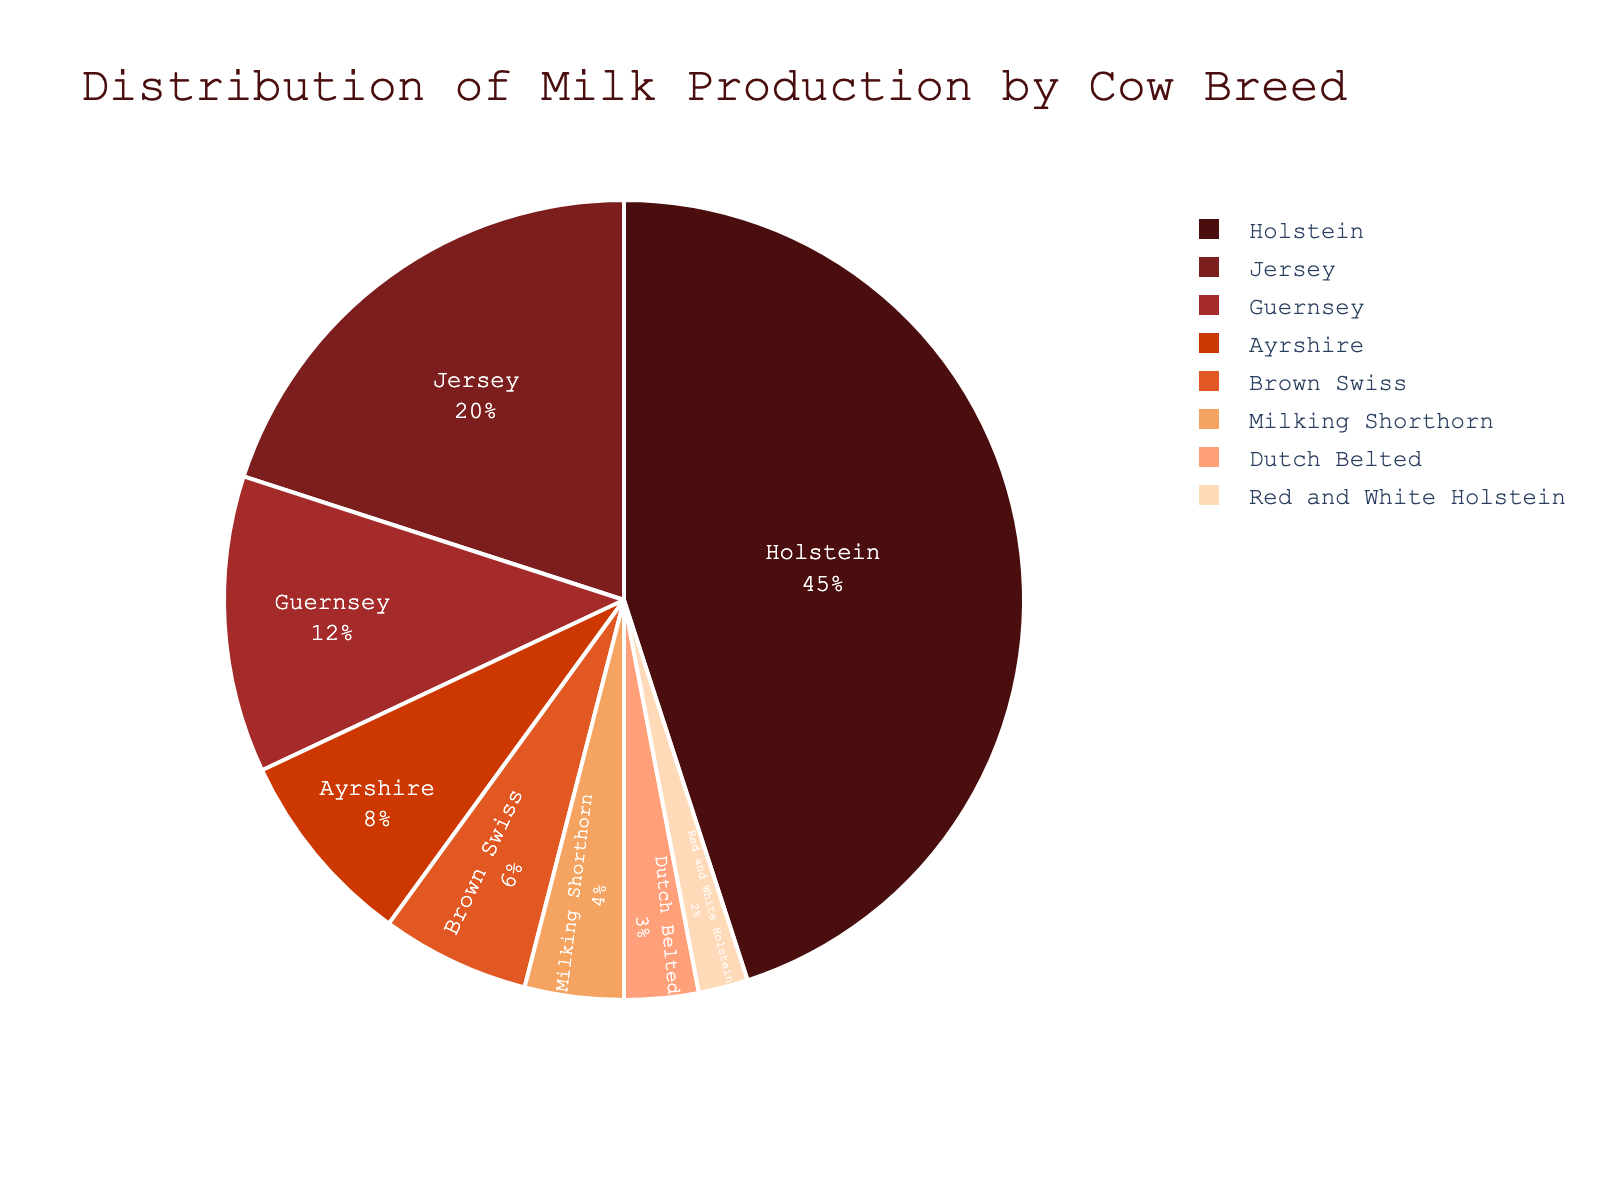Which breed produces the most milk? From the pie chart, it's clear that the largest slice, representing 45% of the total milk production, is attributed to the Holstein breed. Thus, Holstein produces the most milk.
Answer: Holstein Which two breeds combined produce less milk than the Jersey breed? By observing the figure, the breeds producing smaller percentages are Red and White Holstein (2%) and Dutch Belted (3%), which sum up to 5%. Since the Jersey breed alone produces 20%, the combination of Red and White Holstein and Dutch Belted makes less milk than the Jersey breed.
Answer: Red and White Holstein and Dutch Belted What is the percentage difference between Holstein and Jersey milk production? Holstein produces 45% of the milk, and Jersey produces 20%. The difference in their production percentages is 45% - 20% = 25%.
Answer: 25% Which breed has the second smallest percentage, and what is it? From the pie chart, the breed with the second smallest percentage is the Dutch Belted breed, with 3%. The Red and White Holstein has the smallest percentage at 2%.
Answer: Dutch Belted and 3% Is the production from Brown Swiss more than twice that of Milking Shorthorn? Brown Swiss contributes 6% to the total production, and Milking Shorthorn contributes 4%. Checking the condition 6% > 2 * 4%, which is false. Therefore, Brown Swiss production is not more than twice that of Milking Shorthorn.
Answer: No What is the total percentage of milk produced by Guernsey, Ayrshire, and Milking Shorthorn breeds? Adding their percentages gives: Guernsey (12%) + Ayrshire (8%) + Milking Shorthorn (4%) = 24%.
Answer: 24% Which breed's milk production is the closest to one-third of Holstein's production? One-third of Holstein's production is approximately 45% / 3 = 15%. The closest percentage to 15% is produced by Guernsey with 12%.
Answer: Guernsey Is the combined production of Brown Swiss and Ayrshire greater than that of the Guernsey breed? Combining the percentages: Brown Swiss (6%) + Ayrshire (8%) = 14%. Comparing with Guernsey's production of 12%, we see that 14% > 12%.
Answer: Yes 